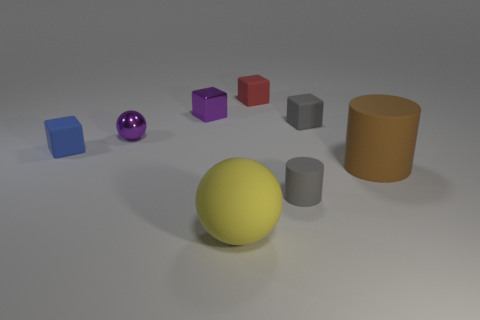Subtract all purple blocks. How many blocks are left? 3 Subtract all red blocks. How many blocks are left? 3 Subtract all balls. How many objects are left? 6 Add 5 blue matte things. How many blue matte things exist? 6 Add 1 small red matte blocks. How many objects exist? 9 Subtract 0 blue spheres. How many objects are left? 8 Subtract 2 cubes. How many cubes are left? 2 Subtract all gray blocks. Subtract all cyan cylinders. How many blocks are left? 3 Subtract all green balls. How many gray cubes are left? 1 Subtract all big brown cylinders. Subtract all matte cubes. How many objects are left? 4 